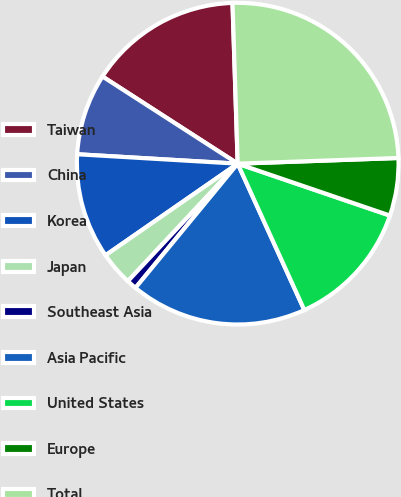<chart> <loc_0><loc_0><loc_500><loc_500><pie_chart><fcel>Taiwan<fcel>China<fcel>Korea<fcel>Japan<fcel>Southeast Asia<fcel>Asia Pacific<fcel>United States<fcel>Europe<fcel>Total<nl><fcel>15.37%<fcel>8.18%<fcel>10.58%<fcel>3.39%<fcel>1.0%<fcel>17.76%<fcel>12.97%<fcel>5.79%<fcel>24.95%<nl></chart> 